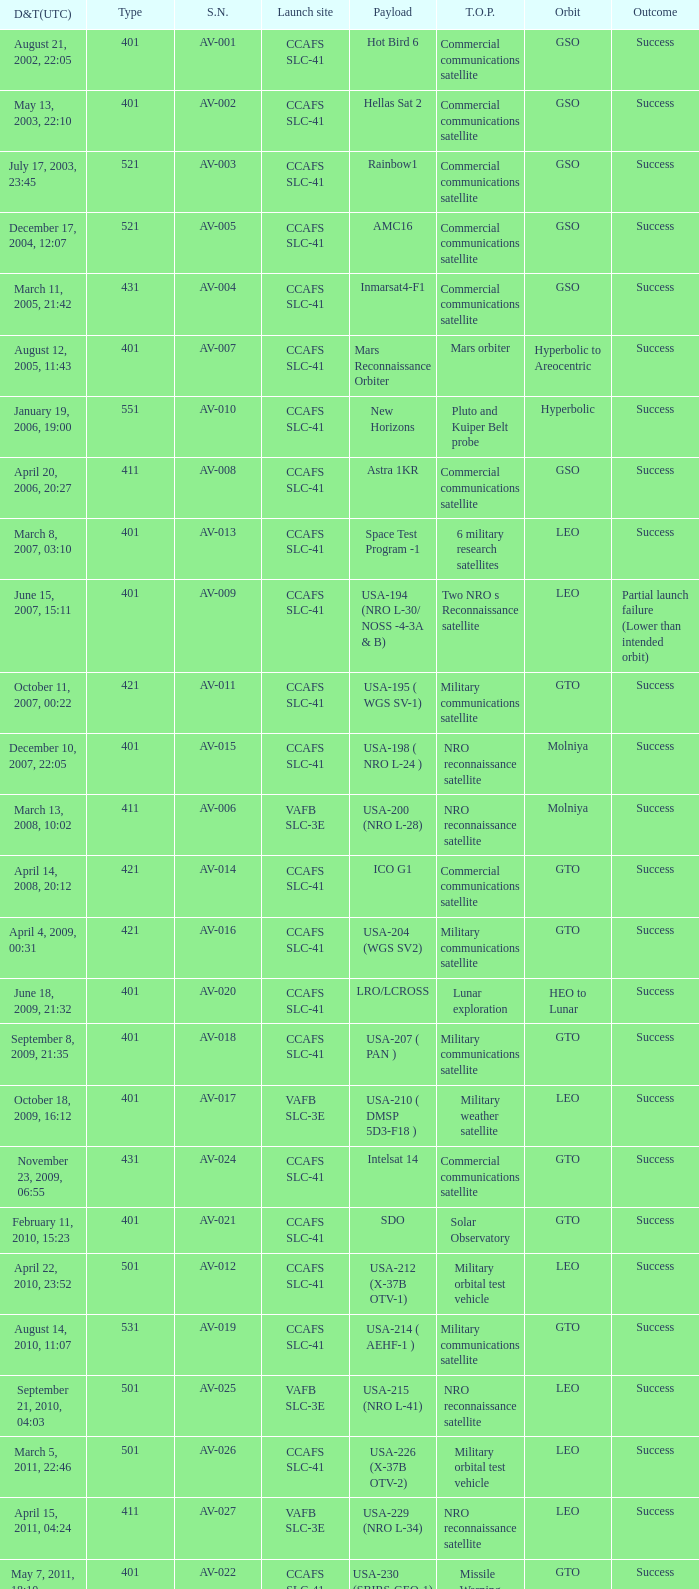What payload was on November 26, 2011, 15:02? Mars rover. 